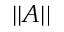<formula> <loc_0><loc_0><loc_500><loc_500>| | A | |</formula> 